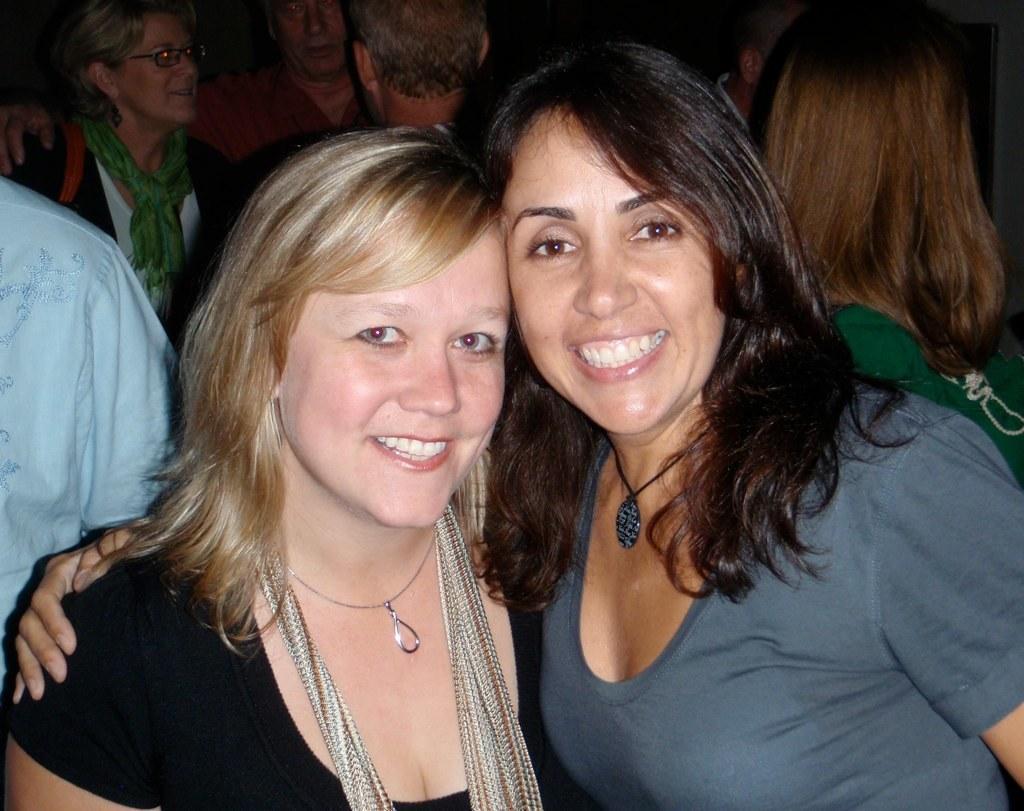Can you describe this image briefly? As we can see in the image there are group of people. The woman standing on the left side is wearing black color dress and the woman on the right side is wearing blue color dress. The background is little dark. 